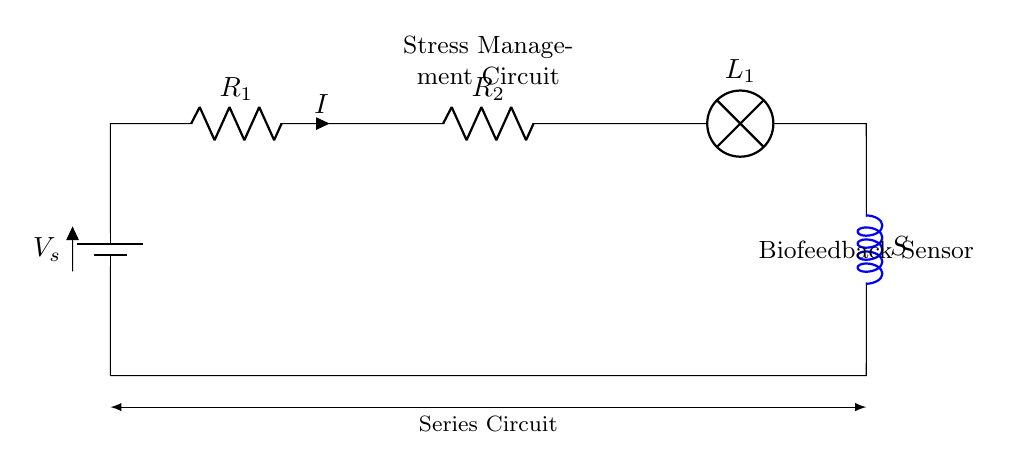What are the components in this circuit? The circuit consists of a battery, two resistors, a lamp, and a biofeedback sensor represented as an inductor. Each component is connected in series, forming a complete circuit.
Answer: battery, two resistors, lamp, biofeedback sensor What is the role of the lamp in this circuit? The lamp indicates the flow of current in the circuit. When the circuit is complete and current flows, the lamp lights up, signifying that the biofeedback device is powered and functioning.
Answer: indicator of current flow What is the total resistance in the circuit? The total resistance in a series circuit is the sum of the individual resistances. Since there are two resistors, the total resistance is the value of R1 plus the value of R2.
Answer: R1 + R2 What would happen if one component fails? In a series circuit, if one component fails (like a resistor or the lamp), the entire circuit would open, and no current would flow. This is because all components are interconnected such that current must pass through each component sequentially.
Answer: circuit opens, no current flows How is the current affected by the resistance? According to Ohm's law, the current in the circuit is inversely related to the total resistance. With a higher resistance (R1 + R2), the current will decrease, assuming the voltage from the battery remains constant.
Answer: current decreases with increased resistance 